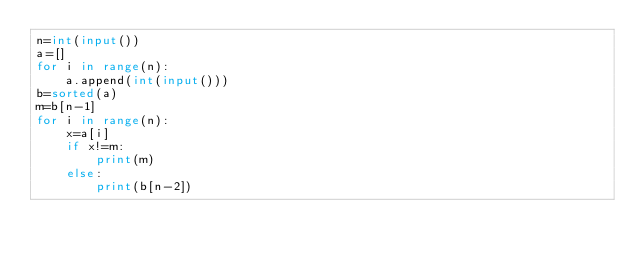Convert code to text. <code><loc_0><loc_0><loc_500><loc_500><_Python_>n=int(input())
a=[]
for i in range(n):
    a.append(int(input()))
b=sorted(a)
m=b[n-1]
for i in range(n):
    x=a[i]
    if x!=m:
        print(m)
    else:
        print(b[n-2])</code> 